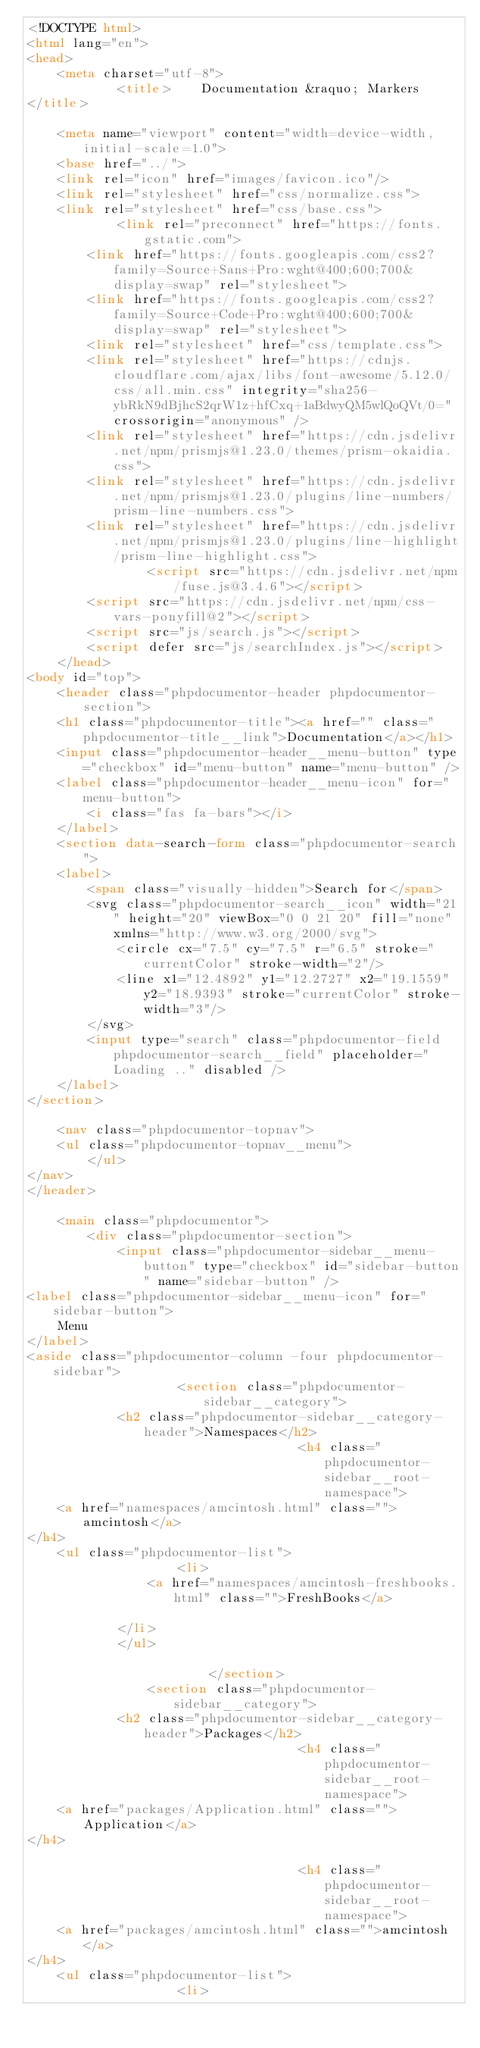Convert code to text. <code><loc_0><loc_0><loc_500><loc_500><_HTML_><!DOCTYPE html>
<html lang="en">
<head>
    <meta charset="utf-8">
            <title>    Documentation &raquo; Markers
</title>
    
    <meta name="viewport" content="width=device-width, initial-scale=1.0">
    <base href="../">
    <link rel="icon" href="images/favicon.ico"/>
    <link rel="stylesheet" href="css/normalize.css">
    <link rel="stylesheet" href="css/base.css">
            <link rel="preconnect" href="https://fonts.gstatic.com">
        <link href="https://fonts.googleapis.com/css2?family=Source+Sans+Pro:wght@400;600;700&display=swap" rel="stylesheet">
        <link href="https://fonts.googleapis.com/css2?family=Source+Code+Pro:wght@400;600;700&display=swap" rel="stylesheet">
        <link rel="stylesheet" href="css/template.css">
        <link rel="stylesheet" href="https://cdnjs.cloudflare.com/ajax/libs/font-awesome/5.12.0/css/all.min.css" integrity="sha256-ybRkN9dBjhcS2qrW1z+hfCxq+1aBdwyQM5wlQoQVt/0=" crossorigin="anonymous" />
        <link rel="stylesheet" href="https://cdn.jsdelivr.net/npm/prismjs@1.23.0/themes/prism-okaidia.css">
        <link rel="stylesheet" href="https://cdn.jsdelivr.net/npm/prismjs@1.23.0/plugins/line-numbers/prism-line-numbers.css">
        <link rel="stylesheet" href="https://cdn.jsdelivr.net/npm/prismjs@1.23.0/plugins/line-highlight/prism-line-highlight.css">
                <script src="https://cdn.jsdelivr.net/npm/fuse.js@3.4.6"></script>
        <script src="https://cdn.jsdelivr.net/npm/css-vars-ponyfill@2"></script>
        <script src="js/search.js"></script>
        <script defer src="js/searchIndex.js"></script>
    </head>
<body id="top">
    <header class="phpdocumentor-header phpdocumentor-section">
    <h1 class="phpdocumentor-title"><a href="" class="phpdocumentor-title__link">Documentation</a></h1>
    <input class="phpdocumentor-header__menu-button" type="checkbox" id="menu-button" name="menu-button" />
    <label class="phpdocumentor-header__menu-icon" for="menu-button">
        <i class="fas fa-bars"></i>
    </label>
    <section data-search-form class="phpdocumentor-search">
    <label>
        <span class="visually-hidden">Search for</span>
        <svg class="phpdocumentor-search__icon" width="21" height="20" viewBox="0 0 21 20" fill="none" xmlns="http://www.w3.org/2000/svg">
            <circle cx="7.5" cy="7.5" r="6.5" stroke="currentColor" stroke-width="2"/>
            <line x1="12.4892" y1="12.2727" x2="19.1559" y2="18.9393" stroke="currentColor" stroke-width="3"/>
        </svg>
        <input type="search" class="phpdocumentor-field phpdocumentor-search__field" placeholder="Loading .." disabled />
    </label>
</section>

    <nav class="phpdocumentor-topnav">
    <ul class="phpdocumentor-topnav__menu">
        </ul>
</nav>
</header>

    <main class="phpdocumentor">
        <div class="phpdocumentor-section">
            <input class="phpdocumentor-sidebar__menu-button" type="checkbox" id="sidebar-button" name="sidebar-button" />
<label class="phpdocumentor-sidebar__menu-icon" for="sidebar-button">
    Menu
</label>
<aside class="phpdocumentor-column -four phpdocumentor-sidebar">
                    <section class="phpdocumentor-sidebar__category">
            <h2 class="phpdocumentor-sidebar__category-header">Namespaces</h2>
                                    <h4 class="phpdocumentor-sidebar__root-namespace">
    <a href="namespaces/amcintosh.html" class="">amcintosh</a>
</h4>
    <ul class="phpdocumentor-list">
                    <li>
                <a href="namespaces/amcintosh-freshbooks.html" class="">FreshBooks</a>
                
            </li>
            </ul>

                        </section>
                <section class="phpdocumentor-sidebar__category">
            <h2 class="phpdocumentor-sidebar__category-header">Packages</h2>
                                    <h4 class="phpdocumentor-sidebar__root-namespace">
    <a href="packages/Application.html" class="">Application</a>
</h4>

                                    <h4 class="phpdocumentor-sidebar__root-namespace">
    <a href="packages/amcintosh.html" class="">amcintosh</a>
</h4>
    <ul class="phpdocumentor-list">
                    <li></code> 